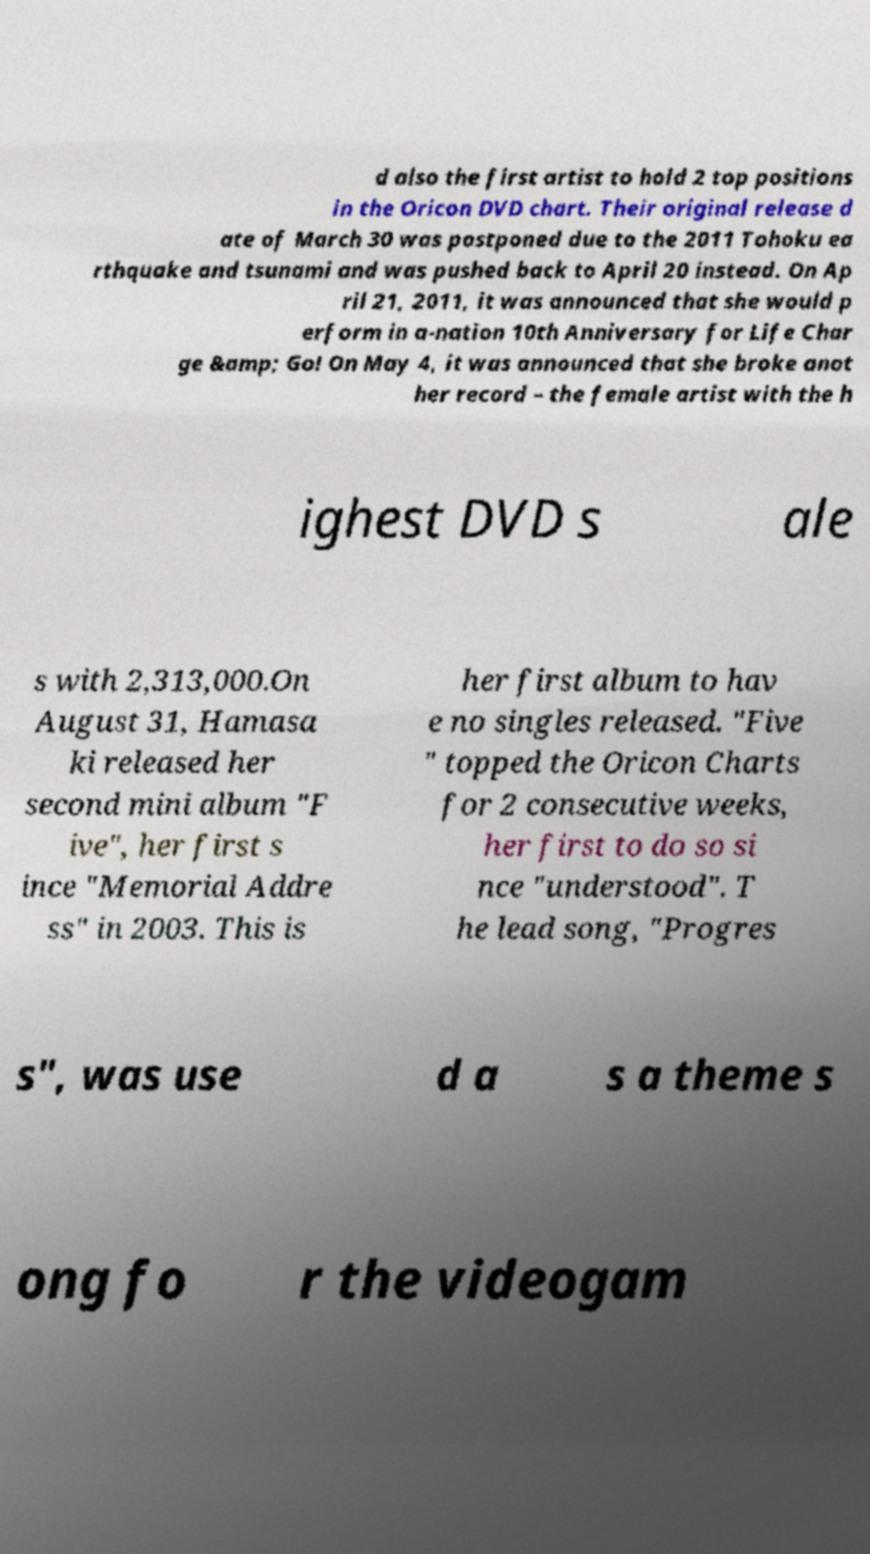Could you extract and type out the text from this image? d also the first artist to hold 2 top positions in the Oricon DVD chart. Their original release d ate of March 30 was postponed due to the 2011 Tohoku ea rthquake and tsunami and was pushed back to April 20 instead. On Ap ril 21, 2011, it was announced that she would p erform in a-nation 10th Anniversary for Life Char ge &amp; Go! On May 4, it was announced that she broke anot her record – the female artist with the h ighest DVD s ale s with 2,313,000.On August 31, Hamasa ki released her second mini album "F ive", her first s ince "Memorial Addre ss" in 2003. This is her first album to hav e no singles released. "Five " topped the Oricon Charts for 2 consecutive weeks, her first to do so si nce "understood". T he lead song, "Progres s", was use d a s a theme s ong fo r the videogam 